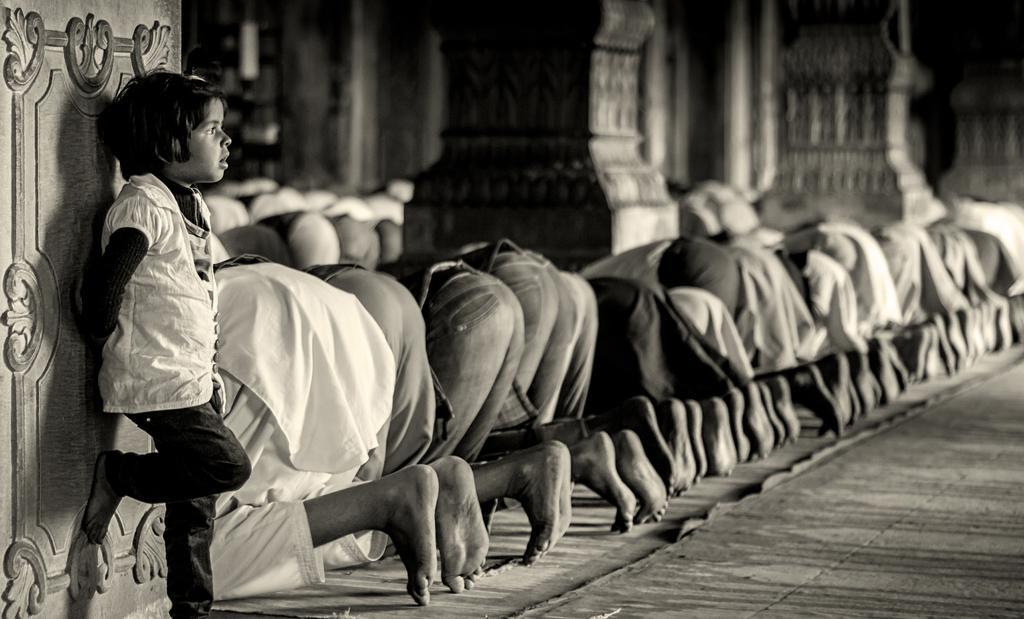Describe this image in one or two sentences. This is a black and white image in this image people are praying, in the background there are pillars, on the left side there is a kid standing near a pillar. 